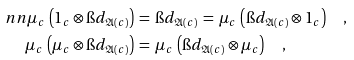Convert formula to latex. <formula><loc_0><loc_0><loc_500><loc_500>\ n n \mu _ { c } \, \left ( 1 _ { c } \otimes \i d _ { \mathfrak { A } ( c ) } \right ) & \, = \, \i d _ { \mathfrak { A } ( c ) } \, = \, \mu _ { c } \, \left ( \i d _ { \mathfrak { A } ( c ) } \otimes 1 _ { c } \right ) \quad , \\ \mu _ { c } \, \left ( \mu _ { c } \otimes \i d _ { \mathfrak { A } ( c ) } \right ) & \, = \, \mu _ { c } \, \left ( \i d _ { \mathfrak { A } ( c ) } \otimes \mu _ { c } \right ) \quad ,</formula> 